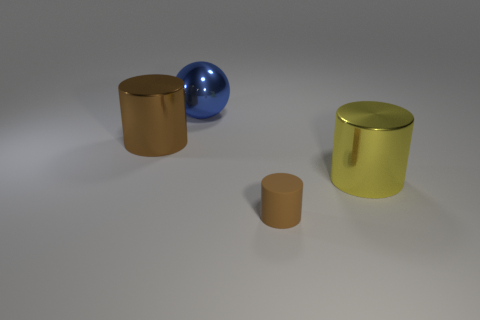Add 3 small red things. How many objects exist? 7 Subtract all spheres. How many objects are left? 3 Subtract all brown metal cylinders. Subtract all small purple metallic cylinders. How many objects are left? 3 Add 4 large brown objects. How many large brown objects are left? 5 Add 3 small metallic spheres. How many small metallic spheres exist? 3 Subtract 0 green cubes. How many objects are left? 4 